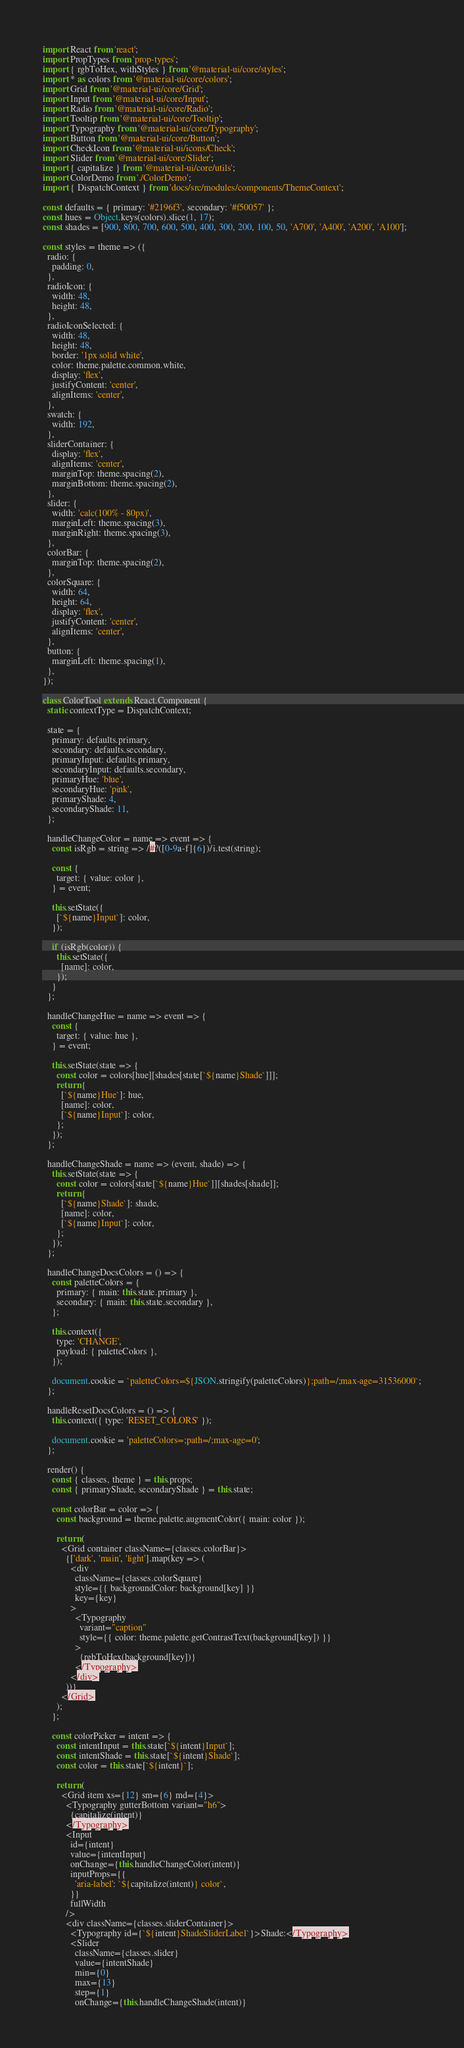<code> <loc_0><loc_0><loc_500><loc_500><_JavaScript_>import React from 'react';
import PropTypes from 'prop-types';
import { rgbToHex, withStyles } from '@material-ui/core/styles';
import * as colors from '@material-ui/core/colors';
import Grid from '@material-ui/core/Grid';
import Input from '@material-ui/core/Input';
import Radio from '@material-ui/core/Radio';
import Tooltip from '@material-ui/core/Tooltip';
import Typography from '@material-ui/core/Typography';
import Button from '@material-ui/core/Button';
import CheckIcon from '@material-ui/icons/Check';
import Slider from '@material-ui/core/Slider';
import { capitalize } from '@material-ui/core/utils';
import ColorDemo from './ColorDemo';
import { DispatchContext } from 'docs/src/modules/components/ThemeContext';

const defaults = { primary: '#2196f3', secondary: '#f50057' };
const hues = Object.keys(colors).slice(1, 17);
const shades = [900, 800, 700, 600, 500, 400, 300, 200, 100, 50, 'A700', 'A400', 'A200', 'A100'];

const styles = theme => ({
  radio: {
    padding: 0,
  },
  radioIcon: {
    width: 48,
    height: 48,
  },
  radioIconSelected: {
    width: 48,
    height: 48,
    border: '1px solid white',
    color: theme.palette.common.white,
    display: 'flex',
    justifyContent: 'center',
    alignItems: 'center',
  },
  swatch: {
    width: 192,
  },
  sliderContainer: {
    display: 'flex',
    alignItems: 'center',
    marginTop: theme.spacing(2),
    marginBottom: theme.spacing(2),
  },
  slider: {
    width: 'calc(100% - 80px)',
    marginLeft: theme.spacing(3),
    marginRight: theme.spacing(3),
  },
  colorBar: {
    marginTop: theme.spacing(2),
  },
  colorSquare: {
    width: 64,
    height: 64,
    display: 'flex',
    justifyContent: 'center',
    alignItems: 'center',
  },
  button: {
    marginLeft: theme.spacing(1),
  },
});

class ColorTool extends React.Component {
  static contextType = DispatchContext;

  state = {
    primary: defaults.primary,
    secondary: defaults.secondary,
    primaryInput: defaults.primary,
    secondaryInput: defaults.secondary,
    primaryHue: 'blue',
    secondaryHue: 'pink',
    primaryShade: 4,
    secondaryShade: 11,
  };

  handleChangeColor = name => event => {
    const isRgb = string => /#?([0-9a-f]{6})/i.test(string);

    const {
      target: { value: color },
    } = event;

    this.setState({
      [`${name}Input`]: color,
    });

    if (isRgb(color)) {
      this.setState({
        [name]: color,
      });
    }
  };

  handleChangeHue = name => event => {
    const {
      target: { value: hue },
    } = event;

    this.setState(state => {
      const color = colors[hue][shades[state[`${name}Shade`]]];
      return {
        [`${name}Hue`]: hue,
        [name]: color,
        [`${name}Input`]: color,
      };
    });
  };

  handleChangeShade = name => (event, shade) => {
    this.setState(state => {
      const color = colors[state[`${name}Hue`]][shades[shade]];
      return {
        [`${name}Shade`]: shade,
        [name]: color,
        [`${name}Input`]: color,
      };
    });
  };

  handleChangeDocsColors = () => {
    const paletteColors = {
      primary: { main: this.state.primary },
      secondary: { main: this.state.secondary },
    };

    this.context({
      type: 'CHANGE',
      payload: { paletteColors },
    });

    document.cookie = `paletteColors=${JSON.stringify(paletteColors)};path=/;max-age=31536000`;
  };

  handleResetDocsColors = () => {
    this.context({ type: 'RESET_COLORS' });

    document.cookie = 'paletteColors=;path=/;max-age=0';
  };

  render() {
    const { classes, theme } = this.props;
    const { primaryShade, secondaryShade } = this.state;

    const colorBar = color => {
      const background = theme.palette.augmentColor({ main: color });

      return (
        <Grid container className={classes.colorBar}>
          {['dark', 'main', 'light'].map(key => (
            <div
              className={classes.colorSquare}
              style={{ backgroundColor: background[key] }}
              key={key}
            >
              <Typography
                variant="caption"
                style={{ color: theme.palette.getContrastText(background[key]) }}
              >
                {rgbToHex(background[key])}
              </Typography>
            </div>
          ))}
        </Grid>
      );
    };

    const colorPicker = intent => {
      const intentInput = this.state[`${intent}Input`];
      const intentShade = this.state[`${intent}Shade`];
      const color = this.state[`${intent}`];

      return (
        <Grid item xs={12} sm={6} md={4}>
          <Typography gutterBottom variant="h6">
            {capitalize(intent)}
          </Typography>
          <Input
            id={intent}
            value={intentInput}
            onChange={this.handleChangeColor(intent)}
            inputProps={{
              'aria-label': `${capitalize(intent)} color`,
            }}
            fullWidth
          />
          <div className={classes.sliderContainer}>
            <Typography id={`${intent}ShadeSliderLabel`}>Shade:</Typography>
            <Slider
              className={classes.slider}
              value={intentShade}
              min={0}
              max={13}
              step={1}
              onChange={this.handleChangeShade(intent)}</code> 